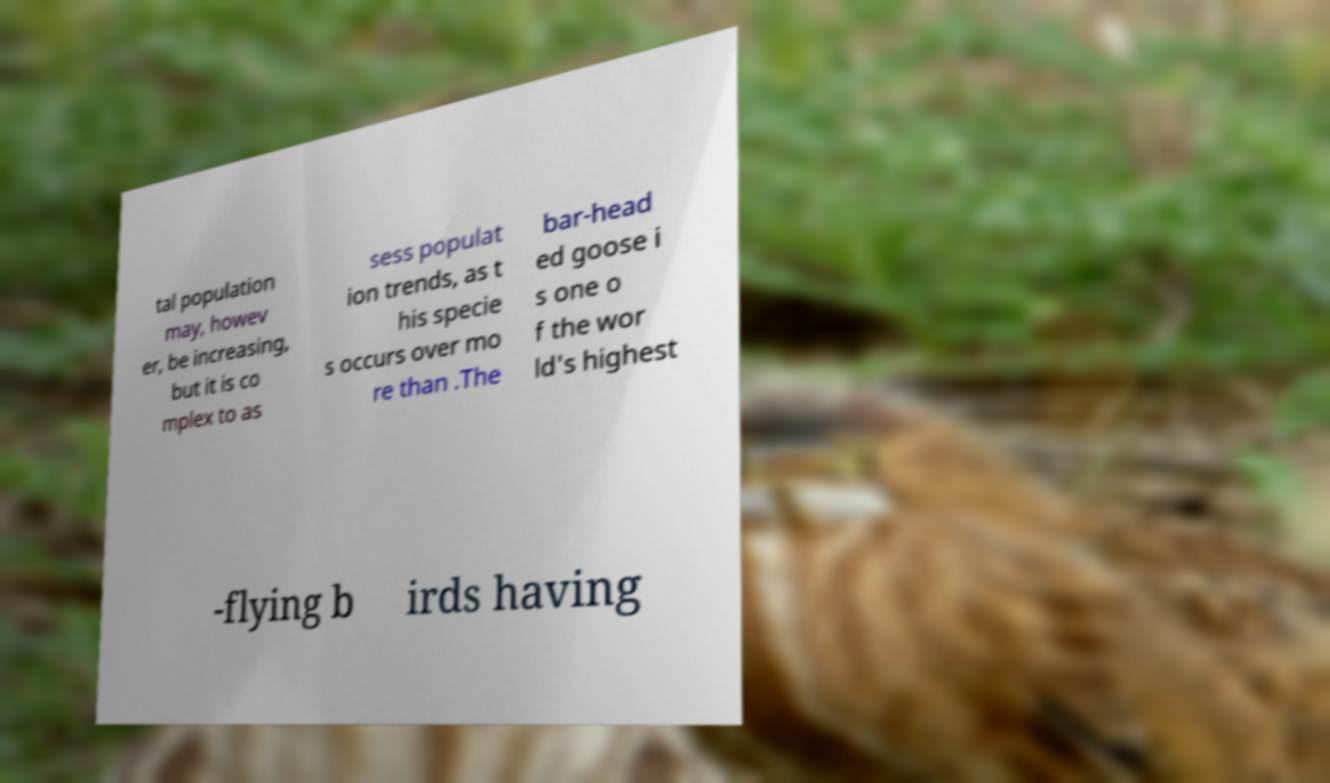Can you accurately transcribe the text from the provided image for me? tal population may, howev er, be increasing, but it is co mplex to as sess populat ion trends, as t his specie s occurs over mo re than .The bar-head ed goose i s one o f the wor ld's highest -flying b irds having 